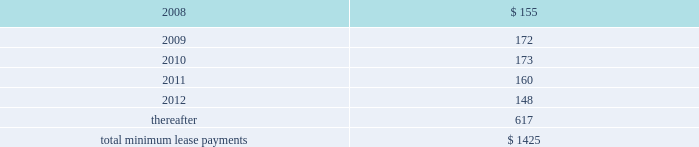Notes to consolidated financial statements ( continued ) note 8 2014commitments and contingencies ( continued ) provide renewal options for terms of 3 to 7 additional years .
Leases for retail space are for terms of 5 to 20 years , the majority of which are for 10 years , and often contain multi-year renewal options .
As of september 29 , 2007 , the company 2019s total future minimum lease payments under noncancelable operating leases were $ 1.4 billion , of which $ 1.1 billion related to leases for retail space .
Rent expense under all operating leases , including both cancelable and noncancelable leases , was $ 151 million , $ 138 million , and $ 140 million in 2007 , 2006 , and 2005 , respectively .
Future minimum lease payments under noncancelable operating leases having remaining terms in excess of one year as of september 29 , 2007 , are as follows ( in millions ) : fiscal years .
Accrued warranty and indemnifications the company offers a basic limited parts and labor warranty on its hardware products .
The basic warranty period for hardware products is typically one year from the date of purchase by the end-user .
The company also offers a 90-day basic warranty for its service parts used to repair the company 2019s hardware products .
The company provides currently for the estimated cost that may be incurred under its basic limited product warranties at the time related revenue is recognized .
Factors considered in determining appropriate accruals for product warranty obligations include the size of the installed base of products subject to warranty protection , historical and projected warranty claim rates , historical and projected cost-per-claim , and knowledge of specific product failures that are outside of the company 2019s typical experience .
The company assesses the adequacy of its preexisting warranty liabilities and adjusts the amounts as necessary based on actual experience and changes in future estimates .
For products accounted for under subscription accounting pursuant to sop no .
97-2 , the company recognizes warranty expense as incurred .
The company periodically provides updates to its applications and system software to maintain the software 2019s compliance with specifications .
The estimated cost to develop such updates is accounted for as warranty costs that are recognized at the time related software revenue is recognized .
Factors considered in determining appropriate accruals related to such updates include the number of units delivered , the number of updates expected to occur , and the historical cost and estimated future cost of the resources necessary to develop these updates. .
What percentage of future minimum lease payments under noncancelable operating leases having remaining terms in excess of one year are due after 2012? 
Computations: (617 / 1425)
Answer: 0.43298. 